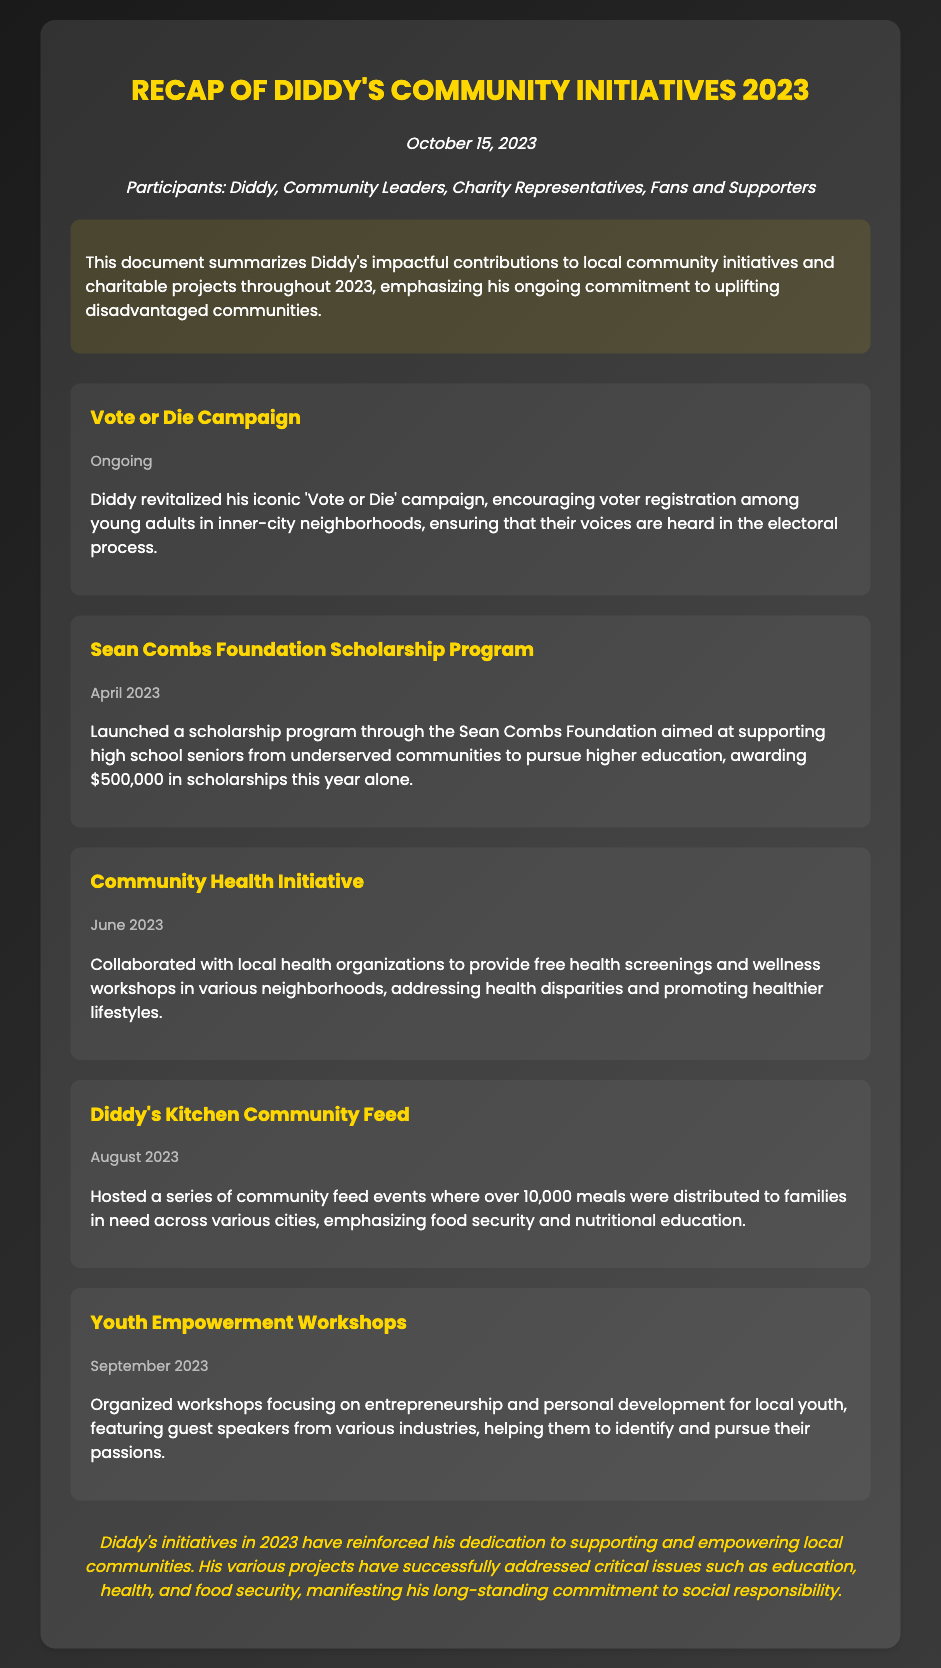What is the date of the meeting? The date of the meeting is explicitly stated at the top of the document.
Answer: October 15, 2023 Who participated in the initiatives meeting? The participants list includes Diddy and others involved in the initiatives, as mentioned in the document.
Answer: Diddy, Community Leaders, Charity Representatives, Fans and Supporters What significant campaign did Diddy revitalize in 2023? The document highlights a specific campaign that Diddy brought back this year.
Answer: Vote or Die Campaign How much money was awarded in scholarships through the Sean Combs Foundation? The document provides a specific figure related to the scholarship program initiated this year.
Answer: $500,000 In which month was the Community Health Initiative launched? The month of the initiative's launch can be found in the section dedicated to that project.
Answer: June 2023 What was the main focus of the Youth Empowerment Workshops? The document outlines the primary area of focus for the workshops organized in September.
Answer: Entrepreneurship and personal development How many meals were distributed during Diddy's Kitchen Community Feed events? A specific number related to the meals distributed is mentioned in the initiative's description.
Answer: 10,000 meals What type of issues did Diddy's initiatives address during 2023? The conclusion of the document summarizes the critical issues tackled through various projects.
Answer: Education, health, and food security 